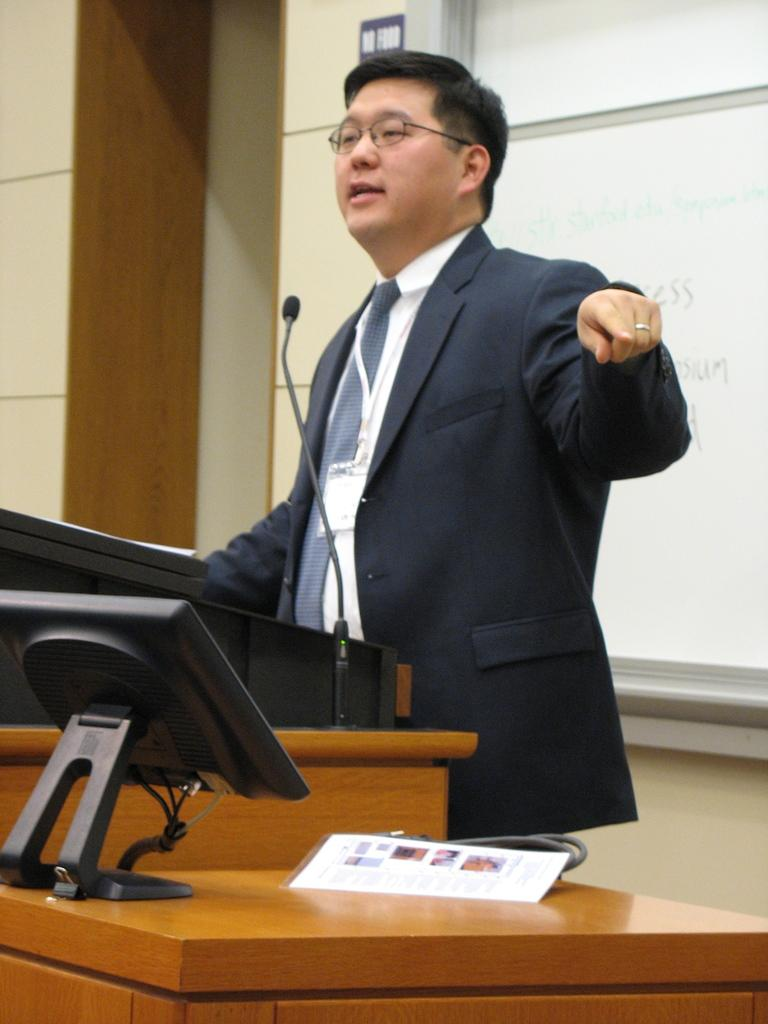What is the man in the image doing? There is a man standing in the image, but his specific activity is not clear. What object is present in the image that is typically used for public speaking? There is a podium in the image, which is often used for public speaking. What device is visible in the image that is used for amplifying sound? There is a microphone in the image, which is used for amplifying sound. What electronic device is visible in the image? There is a computer visible in the image. What type of table is present in the image? There is a wooden table in the image. What is present in the background of the image that is often used for writing or displaying information? There is a blackboard in the background of the image. What type of pump is visible in the image? There is no pump present in the image. 